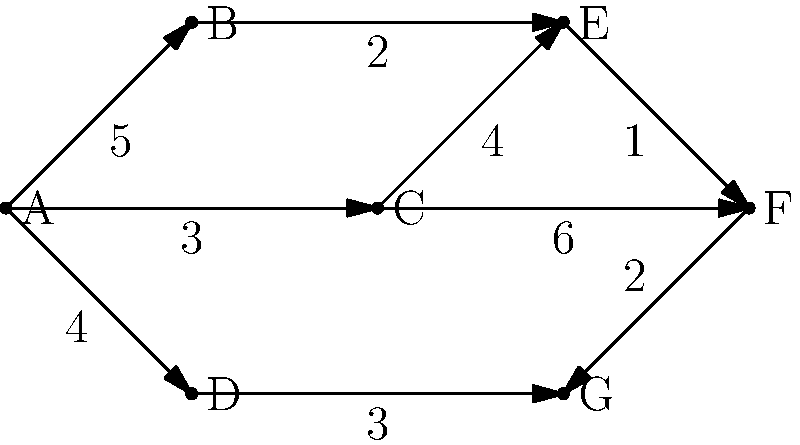As the corporate executive, you've been informed that your company needs to optimize its network routing for efficient data transfer between multiple office locations. The network engineer has provided you with a graph representing the connections between offices, where each node represents an office and each edge represents a data link with its associated cost. What is the minimum total cost to connect all offices in a way that allows data to flow between any two offices, either directly or indirectly? To find the minimum total cost to connect all offices, we need to find the Minimum Spanning Tree (MST) of the given graph. Here's how we can do this using Kruskal's algorithm:

1. Sort all edges by their weight (cost) in ascending order:
   E-F (1), B-E (2), F-G (2), A-C (3), A-D (3), D-G (3), A-B (5), C-F (6)

2. Start with an empty set of edges and add edges one by one, ensuring no cycles are formed:
   - Add E-F (1)
   - Add B-E (2)
   - Add F-G (2)
   - Add A-C (3)
   - Add D-G (3)

3. At this point, we have connected all vertices without forming any cycles. The MST is complete.

4. Calculate the total cost by summing the weights of the selected edges:
   1 + 2 + 2 + 3 + 3 = 11

Therefore, the minimum total cost to connect all offices in a way that allows data to flow between any two offices is 11.
Answer: 11 